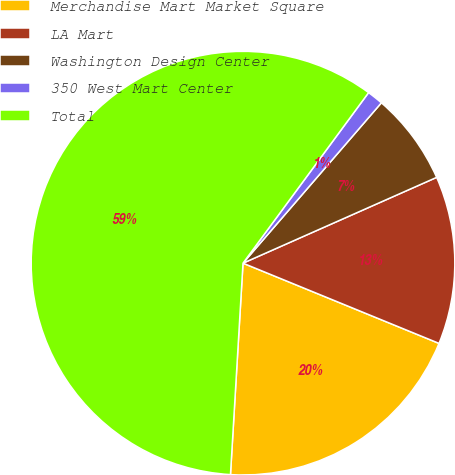<chart> <loc_0><loc_0><loc_500><loc_500><pie_chart><fcel>Merchandise Mart Market Square<fcel>LA Mart<fcel>Washington Design Center<fcel>350 West Mart Center<fcel>Total<nl><fcel>19.76%<fcel>12.82%<fcel>7.03%<fcel>1.23%<fcel>59.16%<nl></chart> 